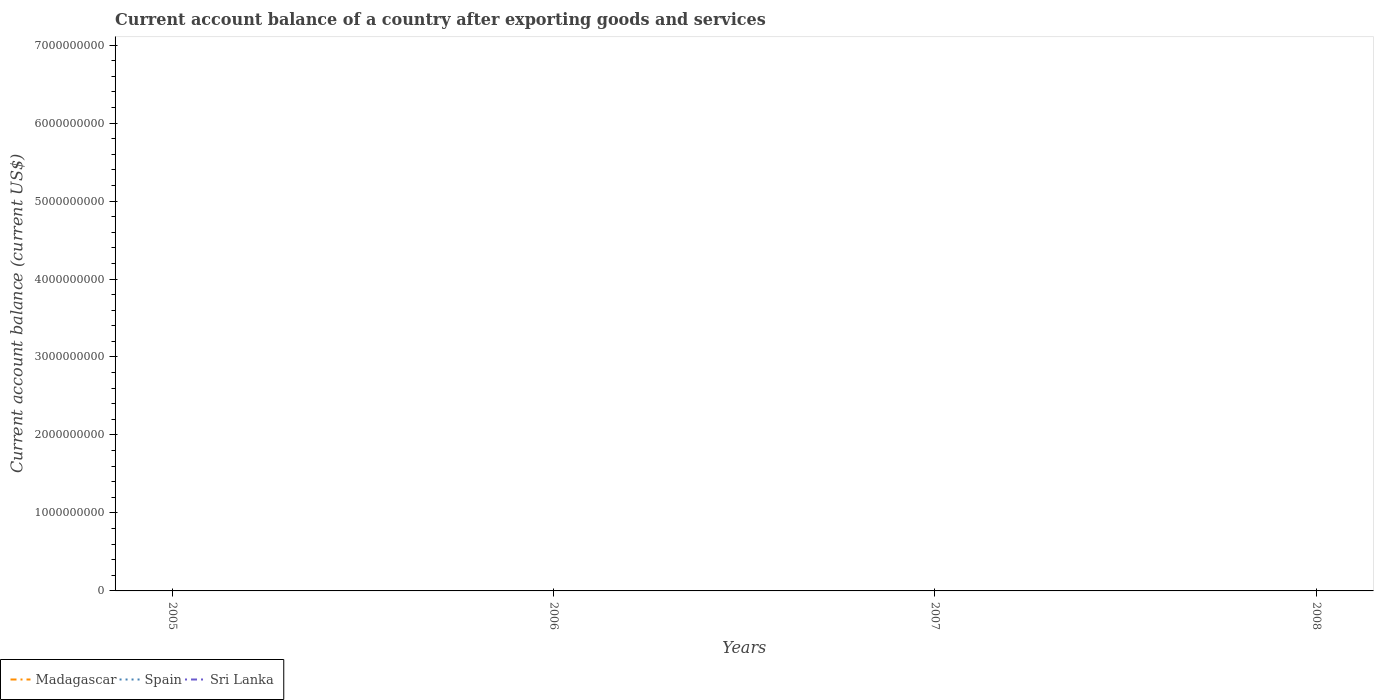Is the number of lines equal to the number of legend labels?
Provide a short and direct response. No. Across all years, what is the maximum account balance in Sri Lanka?
Give a very brief answer. 0. Is the account balance in Sri Lanka strictly greater than the account balance in Madagascar over the years?
Your answer should be compact. No. How many lines are there?
Offer a very short reply. 0. How many years are there in the graph?
Give a very brief answer. 4. What is the difference between two consecutive major ticks on the Y-axis?
Your response must be concise. 1.00e+09. Are the values on the major ticks of Y-axis written in scientific E-notation?
Give a very brief answer. No. Does the graph contain grids?
Provide a succinct answer. No. Where does the legend appear in the graph?
Ensure brevity in your answer.  Bottom left. How many legend labels are there?
Ensure brevity in your answer.  3. How are the legend labels stacked?
Offer a very short reply. Horizontal. What is the title of the graph?
Your answer should be very brief. Current account balance of a country after exporting goods and services. Does "Guinea-Bissau" appear as one of the legend labels in the graph?
Your answer should be very brief. No. What is the label or title of the Y-axis?
Your answer should be compact. Current account balance (current US$). What is the Current account balance (current US$) in Spain in 2005?
Provide a short and direct response. 0. What is the Current account balance (current US$) of Sri Lanka in 2005?
Provide a succinct answer. 0. What is the Current account balance (current US$) of Sri Lanka in 2006?
Your answer should be very brief. 0. What is the Current account balance (current US$) of Madagascar in 2007?
Offer a terse response. 0. What is the Current account balance (current US$) of Madagascar in 2008?
Offer a terse response. 0. What is the Current account balance (current US$) of Spain in 2008?
Offer a very short reply. 0. What is the total Current account balance (current US$) of Madagascar in the graph?
Keep it short and to the point. 0. What is the average Current account balance (current US$) of Sri Lanka per year?
Ensure brevity in your answer.  0. 